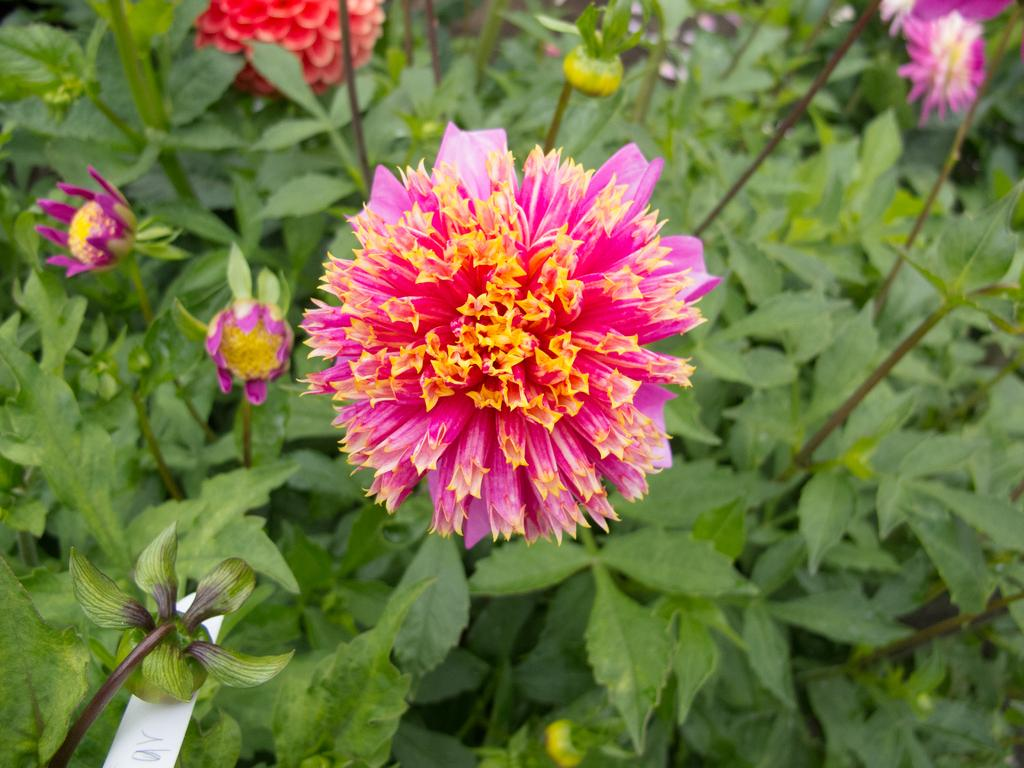What type of living organisms can be seen in the image? There are flowers and plants in the image. Can you describe the plants in the image? The plants in the image are not specified, but they are present alongside the flowers. What type of grape is being used to create harmony in the image? There is no grape present in the image, and the concept of harmony is not applicable to the visual elements depicted. 